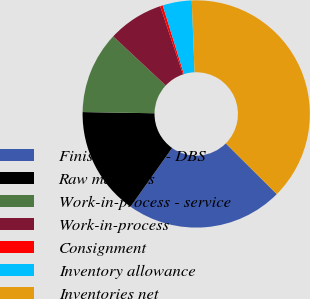Convert chart. <chart><loc_0><loc_0><loc_500><loc_500><pie_chart><fcel>Finished goods - DBS<fcel>Raw materials<fcel>Work-in-process - service<fcel>Work-in-process<fcel>Consignment<fcel>Inventory allowance<fcel>Inventories net<nl><fcel>22.35%<fcel>15.46%<fcel>11.69%<fcel>7.91%<fcel>0.37%<fcel>4.14%<fcel>38.09%<nl></chart> 